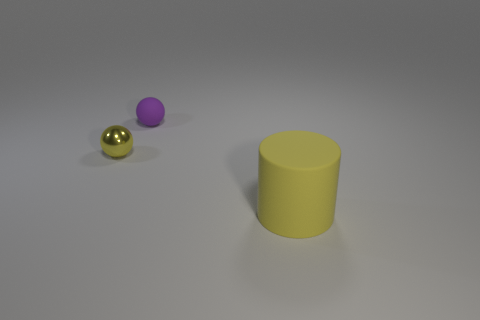Add 1 large matte objects. How many objects exist? 4 Subtract all purple balls. How many green cylinders are left? 0 Subtract 1 yellow cylinders. How many objects are left? 2 Subtract all cylinders. How many objects are left? 2 Subtract 1 cylinders. How many cylinders are left? 0 Subtract all green balls. Subtract all purple cubes. How many balls are left? 2 Subtract all tiny purple matte things. Subtract all small rubber things. How many objects are left? 1 Add 2 large objects. How many large objects are left? 3 Add 2 matte objects. How many matte objects exist? 4 